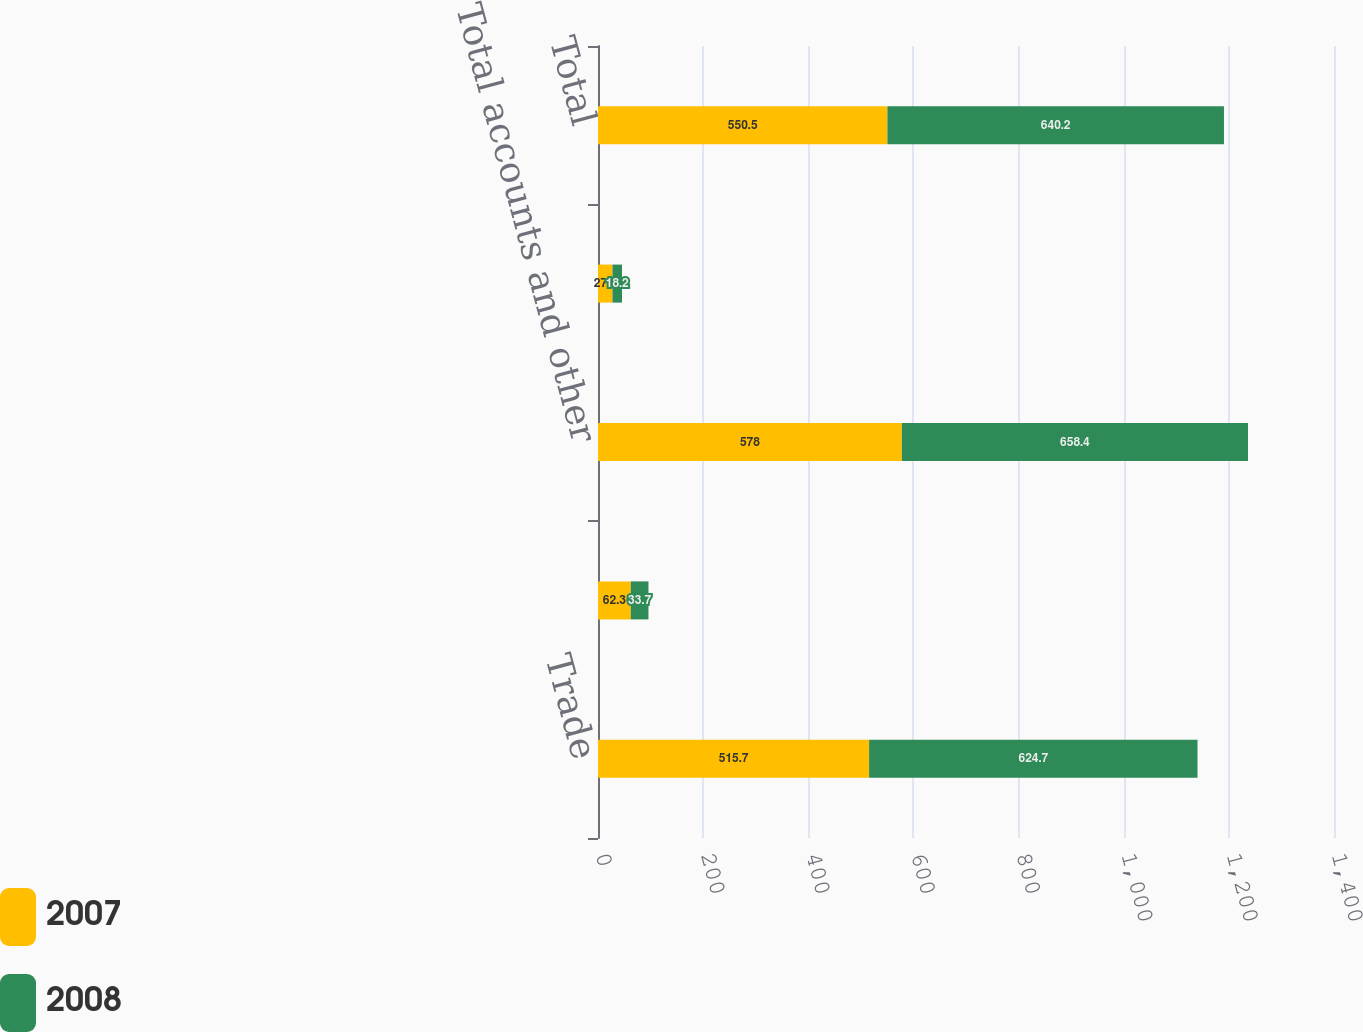Convert chart. <chart><loc_0><loc_0><loc_500><loc_500><stacked_bar_chart><ecel><fcel>Trade<fcel>Other<fcel>Total accounts and other<fcel>Allowance for doubtful<fcel>Total<nl><fcel>2007<fcel>515.7<fcel>62.3<fcel>578<fcel>27.5<fcel>550.5<nl><fcel>2008<fcel>624.7<fcel>33.7<fcel>658.4<fcel>18.2<fcel>640.2<nl></chart> 